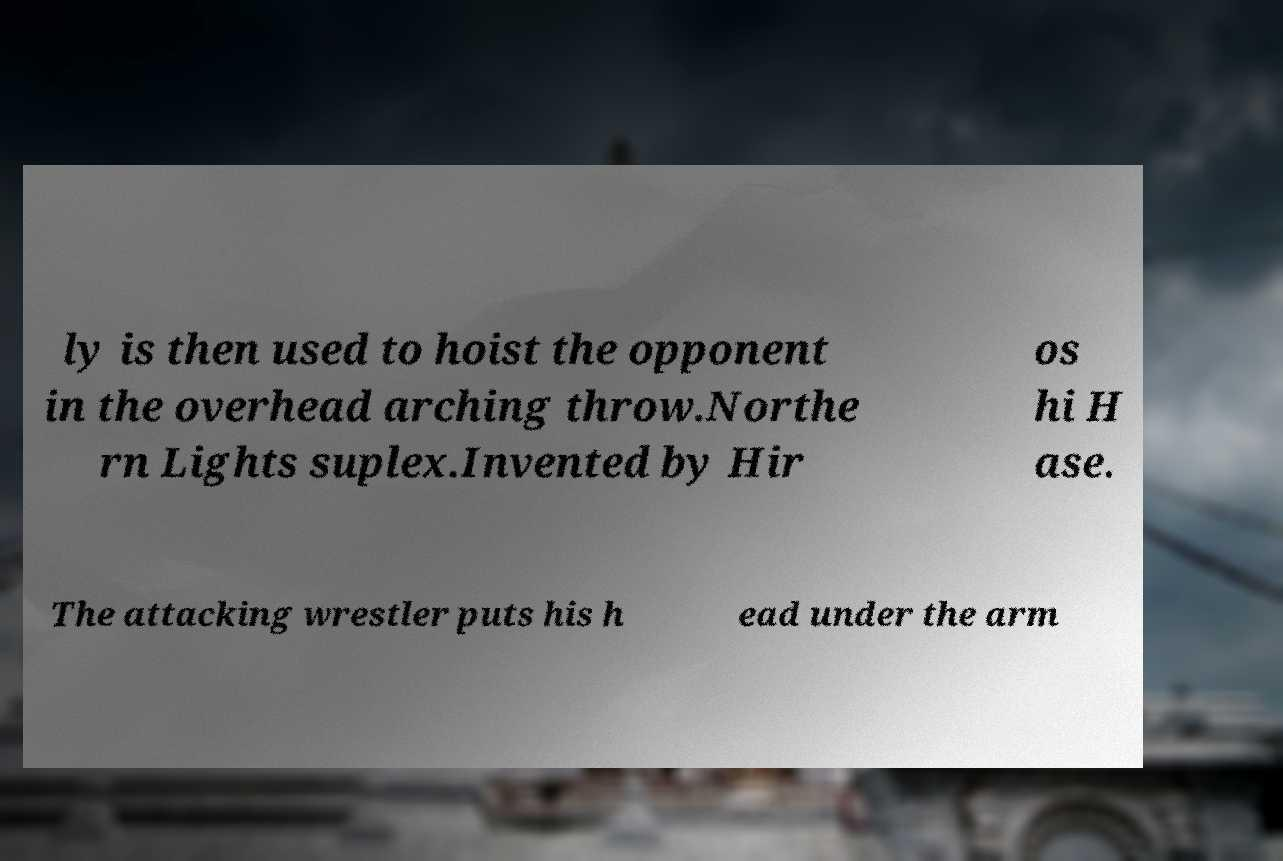Can you accurately transcribe the text from the provided image for me? ly is then used to hoist the opponent in the overhead arching throw.Northe rn Lights suplex.Invented by Hir os hi H ase. The attacking wrestler puts his h ead under the arm 